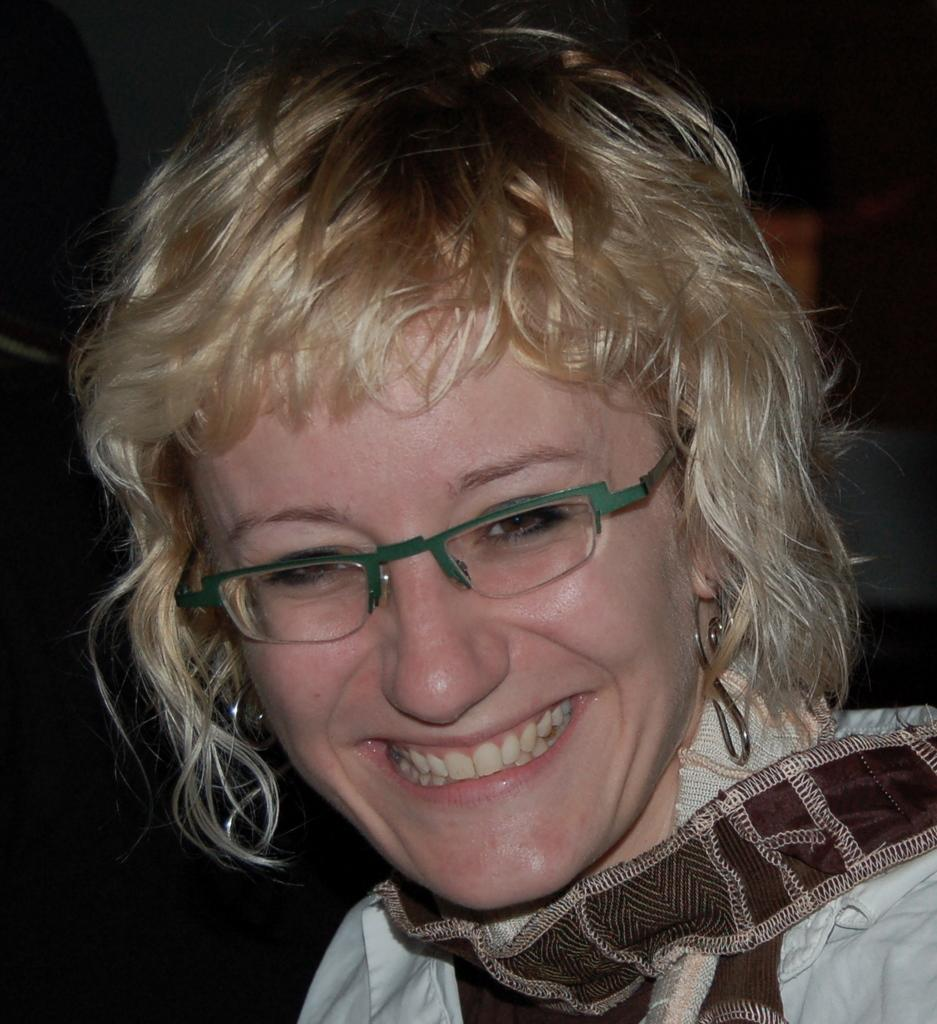Who is the main subject in the image? There is a woman in the image. What accessories is the woman wearing? The woman is wearing spectacles and earrings. What can be observed about the background of the image? The background of the image is dark. What type of cheese is the woman holding in the image? There is no cheese present in the image; the woman is not holding anything. 